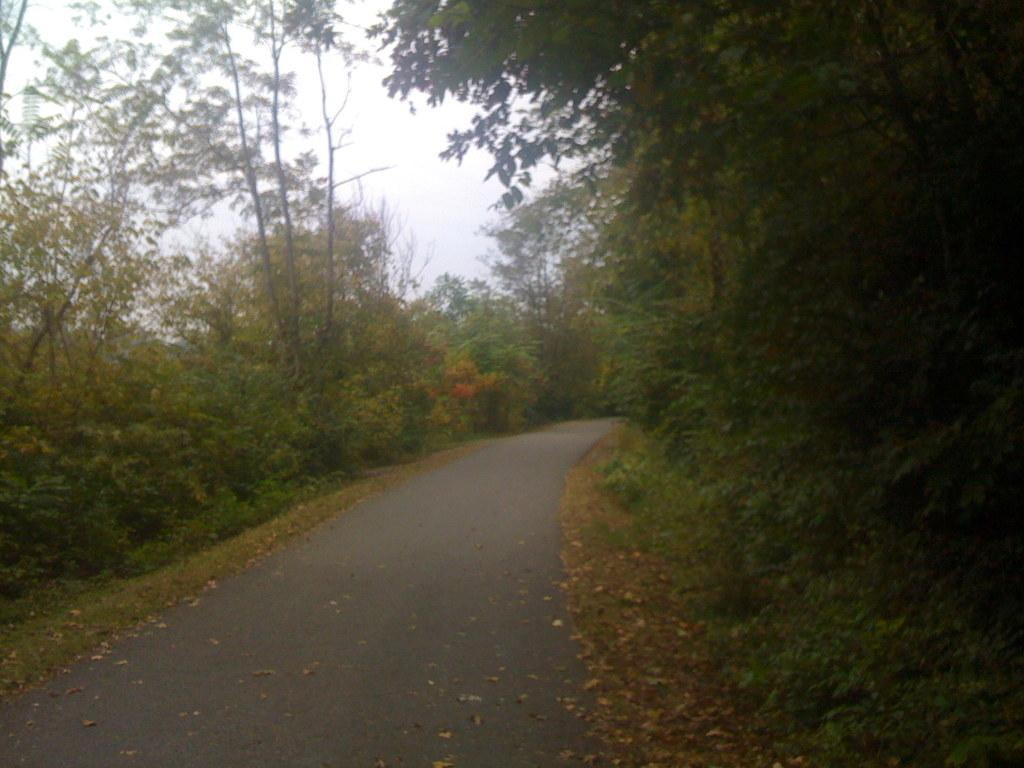What is the main feature in the middle of the image? There is a road at the center of the image. What type of vegetation can be seen on the right side of the image? There are trees on the right side of the image. What type of vegetation can be seen on the left side of the image? There are trees on the left side of the image. What is visible in the background of the image? The sky is visible in the background of the image. What type of gun can be seen in the image? There is no gun present in the image. What color is the copper in the image? There is no copper present in the image. 